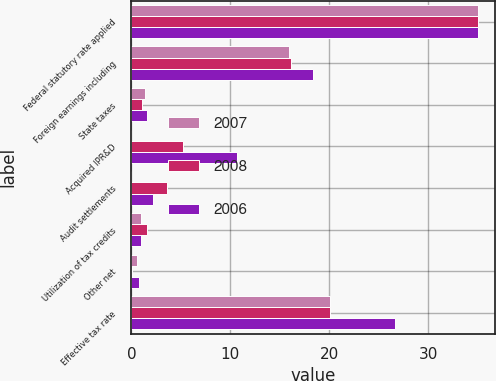<chart> <loc_0><loc_0><loc_500><loc_500><stacked_bar_chart><ecel><fcel>Federal statutory rate applied<fcel>Foreign earnings including<fcel>State taxes<fcel>Acquired IPR&D<fcel>Audit settlements<fcel>Utilization of tax credits<fcel>Other net<fcel>Effective tax rate<nl><fcel>2007<fcel>35<fcel>15.9<fcel>1.4<fcel>0<fcel>0<fcel>1<fcel>0.6<fcel>20.1<nl><fcel>2008<fcel>35<fcel>16.1<fcel>1.1<fcel>5.2<fcel>3.6<fcel>1.6<fcel>0.1<fcel>20.1<nl><fcel>2006<fcel>35<fcel>18.3<fcel>1.6<fcel>10.7<fcel>2.2<fcel>1<fcel>0.8<fcel>26.6<nl></chart> 